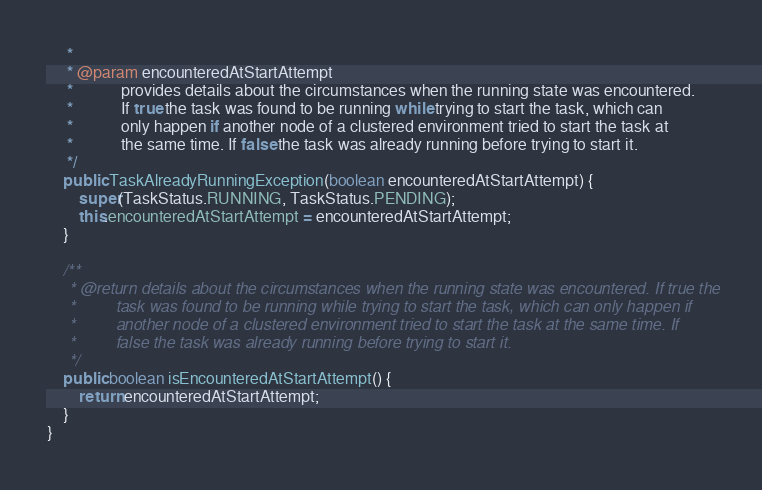Convert code to text. <code><loc_0><loc_0><loc_500><loc_500><_Java_>     *
     * @param encounteredAtStartAttempt
     *            provides details about the circumstances when the running state was encountered.
     *            If true the task was found to be running while trying to start the task, which can
     *            only happen if another node of a clustered environment tried to start the task at
     *            the same time. If false the task was already running before trying to start it.
     */
    public TaskAlreadyRunningException(boolean encounteredAtStartAttempt) {
        super(TaskStatus.RUNNING, TaskStatus.PENDING);
        this.encounteredAtStartAttempt = encounteredAtStartAttempt;
    }

    /**
     * @return details about the circumstances when the running state was encountered. If true the
     *         task was found to be running while trying to start the task, which can only happen if
     *         another node of a clustered environment tried to start the task at the same time. If
     *         false the task was already running before trying to start it.
     */
    public boolean isEncounteredAtStartAttempt() {
        return encounteredAtStartAttempt;
    }
}
</code> 